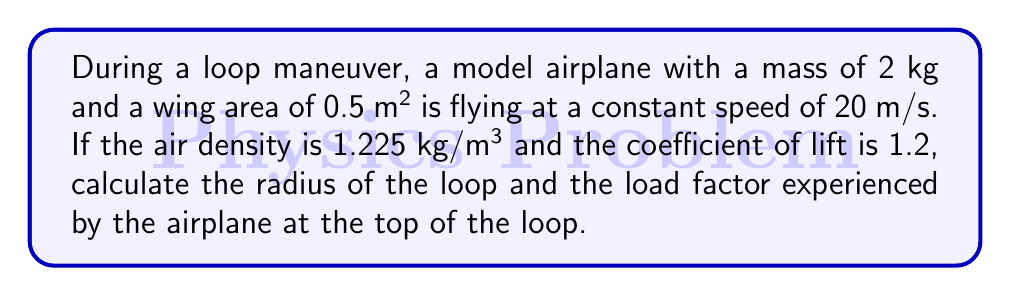Help me with this question. Let's approach this step-by-step:

1) First, we need to calculate the lift force at the top of the loop. At this point, the lift must equal the sum of the weight and the centripetal force:

   $$ L = W + \frac{mv^2}{r} $$

   Where $L$ is lift, $W$ is weight, $m$ is mass, $v$ is velocity, and $r$ is the radius of the loop.

2) We can calculate the weight:
   $$ W = mg = 2 \cdot 9.81 = 19.62 \text{ N} $$

3) The lift force can be calculated using the lift equation:
   $$ L = \frac{1}{2} \rho v^2 S C_L $$
   Where $\rho$ is air density, $S$ is wing area, and $C_L$ is the coefficient of lift.

4) Substituting the given values:
   $$ L = \frac{1}{2} \cdot 1.225 \cdot 20^2 \cdot 0.5 \cdot 1.2 = 147 \text{ N} $$

5) Now we can substitute these values into the equation from step 1:
   $$ 147 = 19.62 + \frac{2 \cdot 20^2}{r} $$

6) Solving for $r$:
   $$ r = \frac{2 \cdot 20^2}{147 - 19.62} = 31.4 \text{ m} $$

7) The load factor is the ratio of lift to weight:
   $$ n = \frac{L}{W} = \frac{147}{19.62} = 7.49 $$

Thus, the radius of the loop is approximately 31.4 m, and the load factor is 7.49.
Answer: Radius: 31.4 m; Load factor: 7.49 